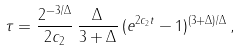<formula> <loc_0><loc_0><loc_500><loc_500>\tau = \frac { 2 ^ { - 3 / \Delta } } { 2 c _ { 2 } } \, \frac { \Delta } { 3 + \Delta } \, ( e ^ { 2 c _ { 2 } t } - 1 ) ^ { ( 3 + \Delta ) / \Delta } \, ,</formula> 